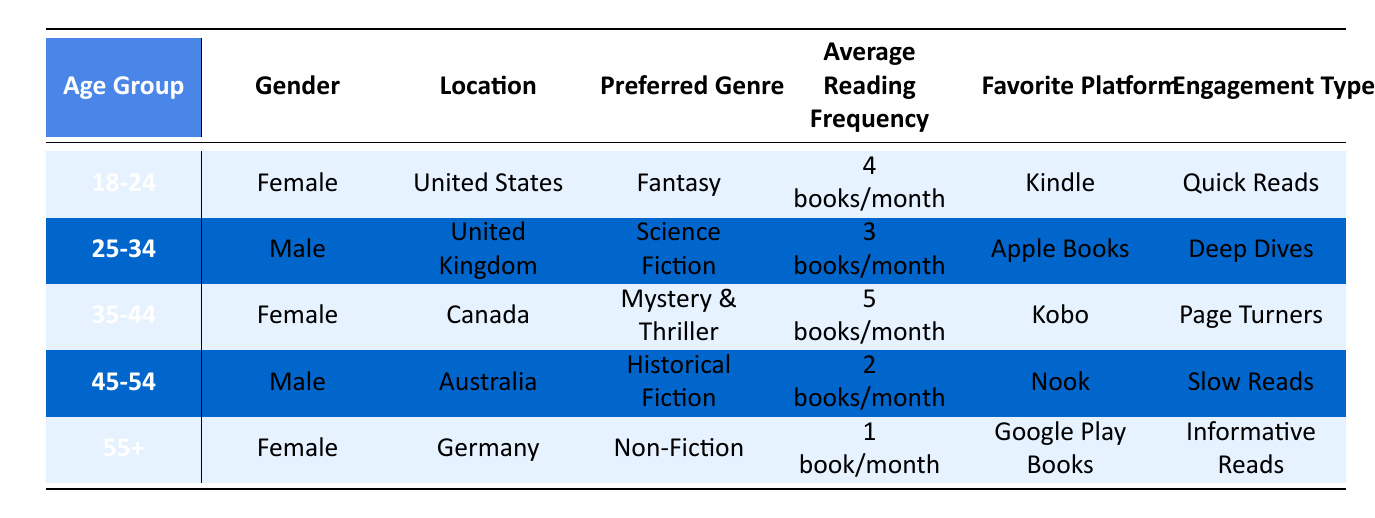What is the preferred genre of readers in the 35-44 age group? The 35-44 age group has a preferred genre listed as Mystery & Thriller in the table.
Answer: Mystery & Thriller How many books does the average reader aged 55 and above read per month? According to the table, the average reading frequency for the 55+ age group is specified as 1 book/month.
Answer: 1 book/month True or False: Readers aged 25-34 prefer the Fantasy genre. The table indicates that readers in this age group prefer Science Fiction, not Fantasy. Thus, this statement is false.
Answer: False What is the average reading frequency for male readers? To find the average, we look at the reading frequencies for males: 3 books/month (25-34 age group) and 2 books/month (45-54 age group). Calculating the average: (3 + 2) / 2 = 2.5 books/month.
Answer: 2.5 books/month Which location has readers engaging primarily in 'Informative Reads'? The table shows that Germany is the location where readers prefer 'Informative Reads,' specifically within the 55+ age group.
Answer: Germany Which engagement type is associated with the preferred genre of Fantasy? The engagement type for the 18-24 age group, who prefer Fantasy, is listed as Quick Reads in the table.
Answer: Quick Reads Is there any age group that prefers Non-Fiction? Yes, the 55+ age group prefers Non-Fiction, as stated in the table.
Answer: Yes What is the frequency of book reading for the 45-54 age group compared to the 35-44 age group? The 45-54 age group reads 2 books/month, while the 35-44 age group reads 5 books/month. Therefore, the 35-44 age group reads more frequently than the 45-54 group. The difference is 5 - 2 = 3 books/month.
Answer: 3 books/month Are there more male or female respondents in the dataset? By counting the gender distribution: 3 females (18-24, 35-44, 55+) and 2 males (25-34, 45-54). This shows there are more female respondents than male ones.
Answer: Female respondents are more 